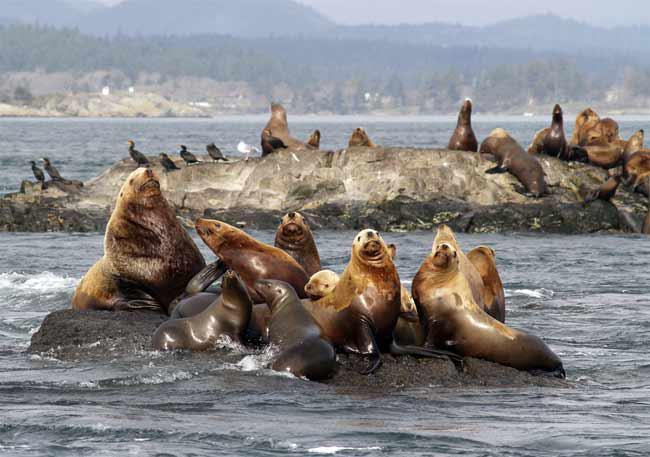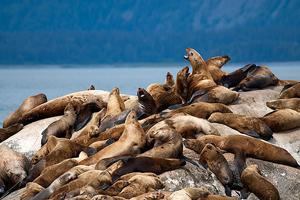The first image is the image on the left, the second image is the image on the right. Considering the images on both sides, is "There are no more than 8 seals in the image on the left." valid? Answer yes or no. No. 